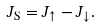<formula> <loc_0><loc_0><loc_500><loc_500>J _ { \text {S} } = J _ { \uparrow } - J _ { \downarrow } .</formula> 